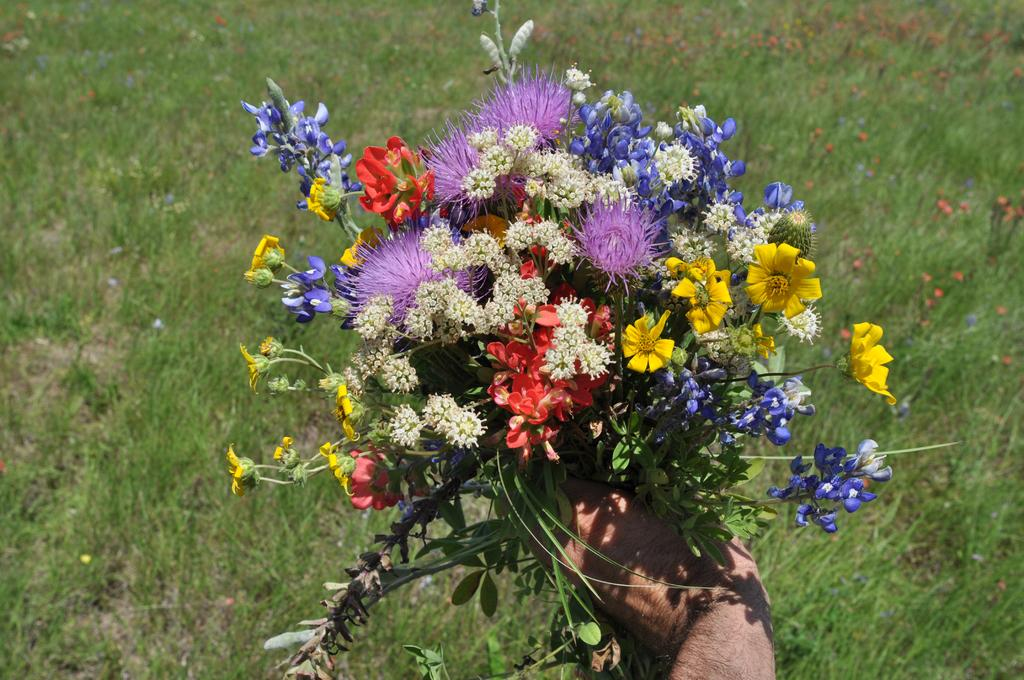What is being held in the person's hand in the image? There is a person's hand holding flowers in the image. What type of surface is visible beneath the person's hand? There is grass on the ground in the image. What type of metal object can be seen in the image? There is no metal object present in the image. What kind of doll is sitting on the grass in the image? There is no doll present in the image; it only shows a person's hand holding flowers and grass on the ground. 